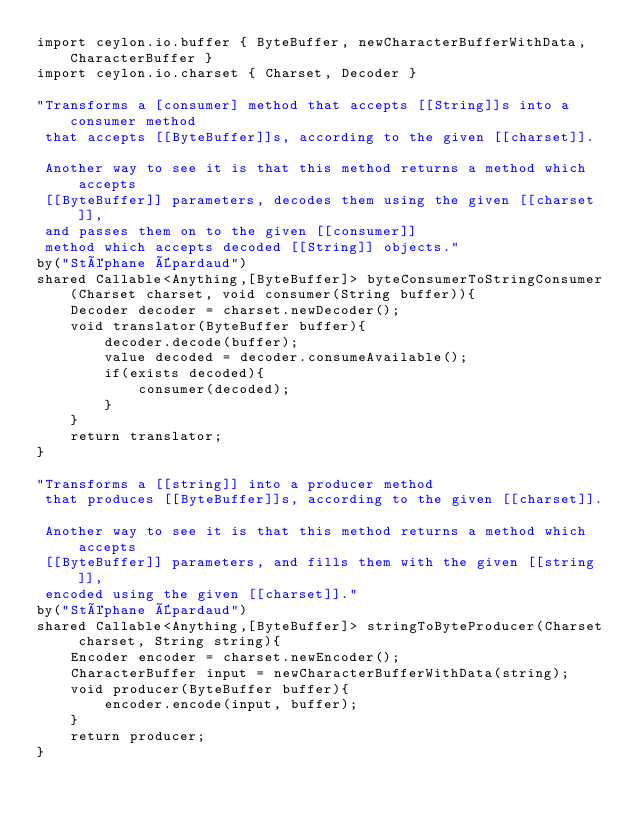Convert code to text. <code><loc_0><loc_0><loc_500><loc_500><_Ceylon_>import ceylon.io.buffer { ByteBuffer, newCharacterBufferWithData, CharacterBuffer }
import ceylon.io.charset { Charset, Decoder }

"Transforms a [consumer] method that accepts [[String]]s into a consumer method
 that accepts [[ByteBuffer]]s, according to the given [[charset]].
 
 Another way to see it is that this method returns a method which accepts
 [[ByteBuffer]] parameters, decodes them using the given [[charset]],
 and passes them on to the given [[consumer]]
 method which accepts decoded [[String]] objects."
by("Stéphane Épardaud")
shared Callable<Anything,[ByteBuffer]> byteConsumerToStringConsumer(Charset charset, void consumer(String buffer)){
    Decoder decoder = charset.newDecoder();
    void translator(ByteBuffer buffer){
        decoder.decode(buffer);
        value decoded = decoder.consumeAvailable();
        if(exists decoded){
            consumer(decoded);
        }
    }
    return translator;
}

"Transforms a [[string]] into a producer method
 that produces [[ByteBuffer]]s, according to the given [[charset]].
 
 Another way to see it is that this method returns a method which accepts
 [[ByteBuffer]] parameters, and fills them with the given [[string]],
 encoded using the given [[charset]]."
by("Stéphane Épardaud")
shared Callable<Anything,[ByteBuffer]> stringToByteProducer(Charset charset, String string){
    Encoder encoder = charset.newEncoder();
    CharacterBuffer input = newCharacterBufferWithData(string);
    void producer(ByteBuffer buffer){
        encoder.encode(input, buffer);
    }
    return producer;
}
</code> 